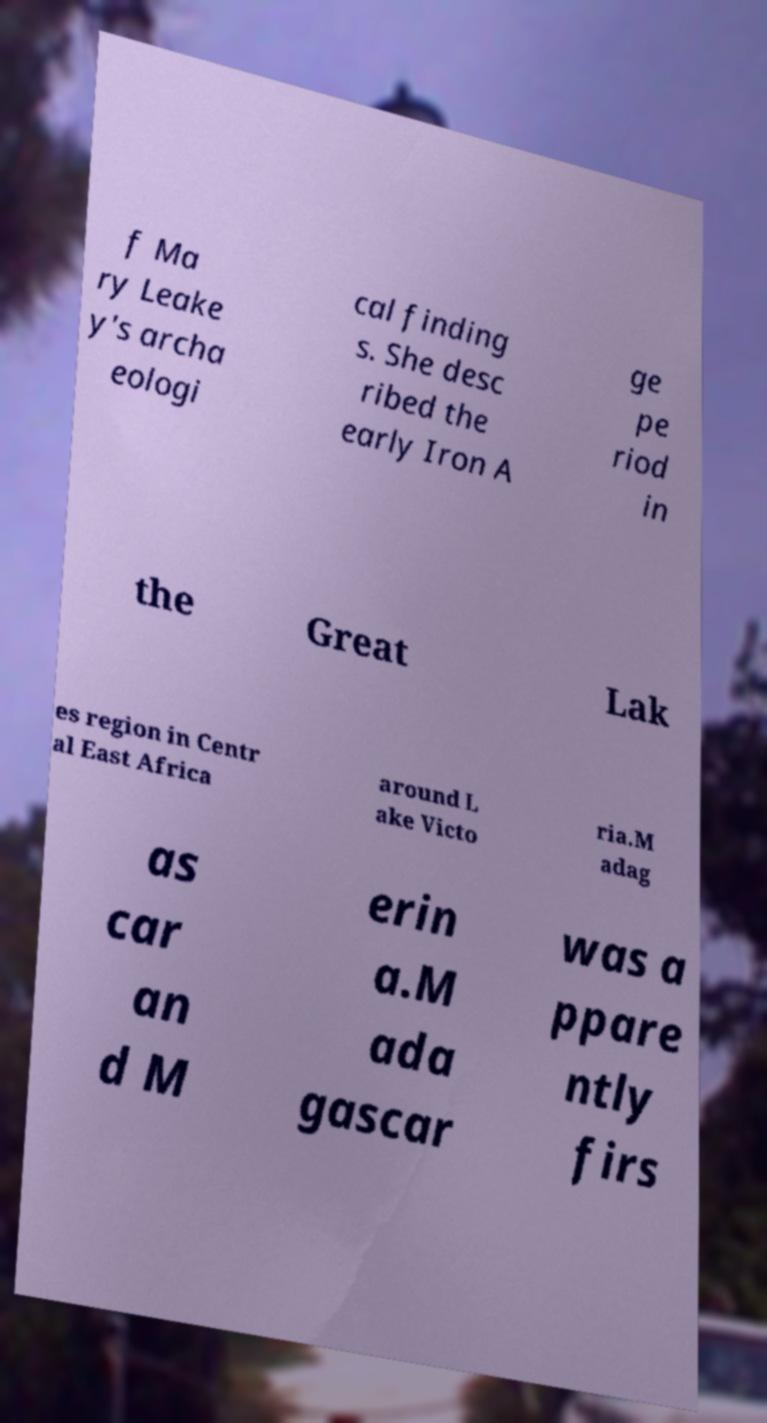Please identify and transcribe the text found in this image. f Ma ry Leake y's archa eologi cal finding s. She desc ribed the early Iron A ge pe riod in the Great Lak es region in Centr al East Africa around L ake Victo ria.M adag as car an d M erin a.M ada gascar was a ppare ntly firs 